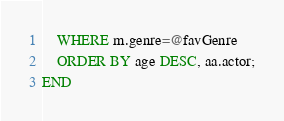<code> <loc_0><loc_0><loc_500><loc_500><_SQL_>    WHERE m.genre=@favGenre
    ORDER BY age DESC, aa.actor;
END</code> 